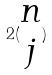<formula> <loc_0><loc_0><loc_500><loc_500>2 ( \begin{matrix} n \\ j \end{matrix} )</formula> 